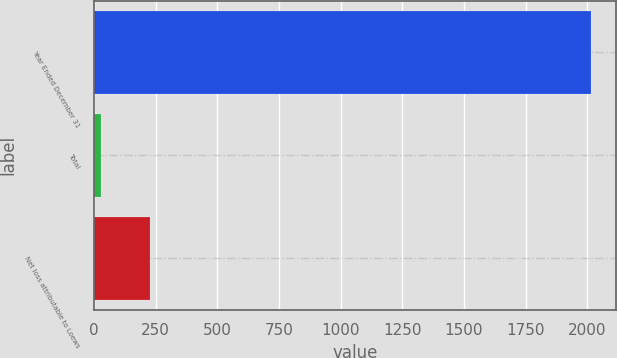Convert chart. <chart><loc_0><loc_0><loc_500><loc_500><bar_chart><fcel>Year Ended December 31<fcel>Total<fcel>Net loss attributable to Loews<nl><fcel>2015<fcel>28<fcel>226.7<nl></chart> 